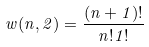Convert formula to latex. <formula><loc_0><loc_0><loc_500><loc_500>w ( n , 2 ) = \frac { ( n + 1 ) ! } { n ! 1 ! }</formula> 